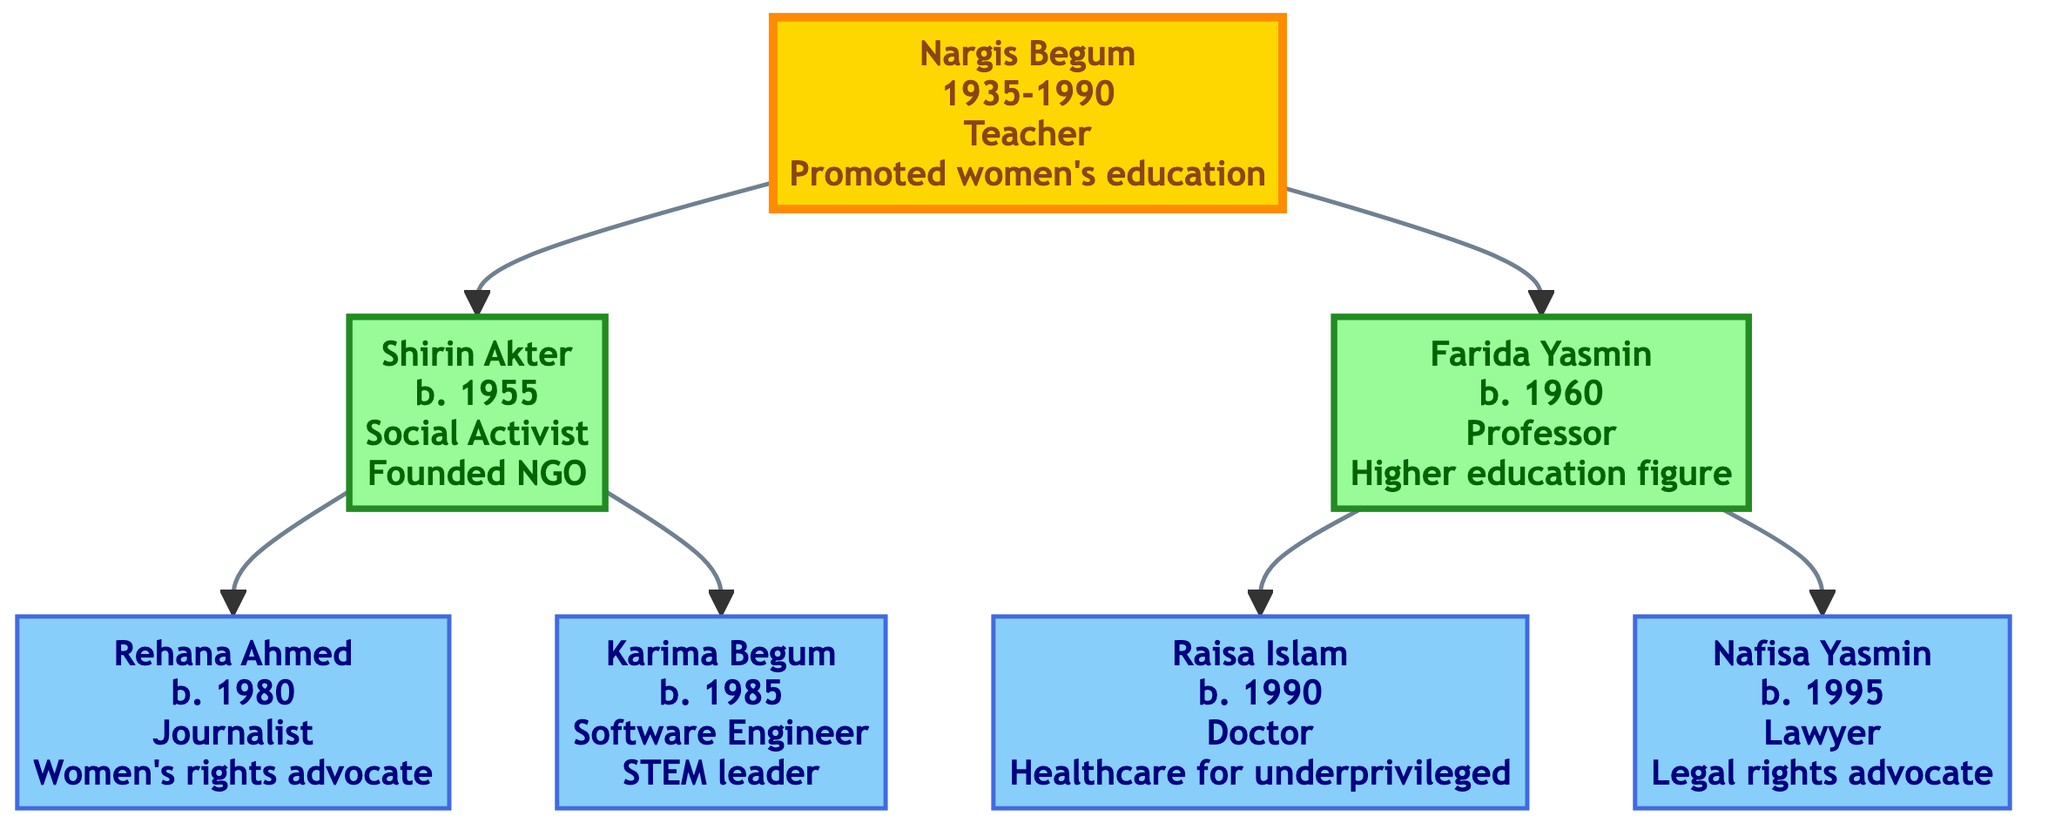What is the occupation of Nargis Begum? The diagram indicates Nargis Begum's occupation is listed directly under her name. It states that she was a Teacher.
Answer: Teacher How many children does Nargis Begum have? By examining the connections from Nargis Begum, it is clear that there are two branches leading to her children, which are Shirin Akter and Farida Yasmin. Therefore, she has two children.
Answer: 2 What influence did Shirin Akter have? The influence of Shirin Akter is detailed under her name in the diagram. It states that she founded an NGO for women's empowerment.
Answer: Founded an NGO for women empowerment Who is the eldest child of Nargis Begum? To find the eldest child, we look at the birthdates of her children. Shirin Akter was born in 1955 and Farida Yasmin in 1960. Since 1955 is earlier than 1960, Shirin Akter is the eldest child.
Answer: Shirin Akter What is the relationship between Rehana Ahmed and Nargis Begum? In the diagram, each child is connected to their parent. Rehana Ahmed is listed as a child of Shirin Akter, who is a direct child of Nargis Begum. Thus, Rehana Ahmed is Nargis Begum's granddaughter.
Answer: Granddaughter How many granddaughters does Nargis Begum have? By counting the female descendants from each of Nargis Begum's daughters, Shirin Akter has two daughters (Rehana Ahmed and Karima Begum), and Farida Yasmin has two daughters (Raisa Islam and Nafisa Yasmin). Therefore, there are four granddaughters.
Answer: 4 Which influential figure in this family tree is a doctor? Raisa Islam is listed as a Doctor under the section for Farida Yasmin’s children. This information can be directly found in the details regarding Raisa Islam's influence and occupation.
Answer: Raisa Islam What is the main influence of Karima Begum? The diagram explicitly states that Karima Begum is a leader in tech initiatives promoting women in STEM, which describes her primary influence.
Answer: Leader in tech initiatives promoting women in STEM 